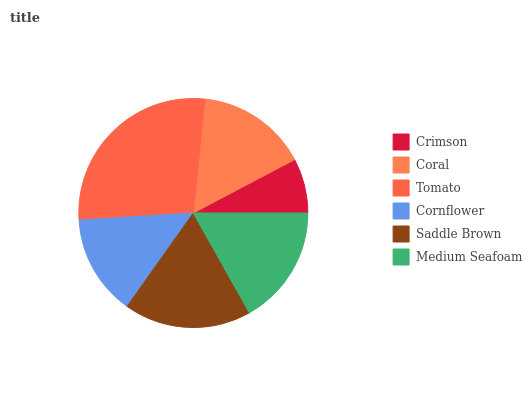Is Crimson the minimum?
Answer yes or no. Yes. Is Tomato the maximum?
Answer yes or no. Yes. Is Coral the minimum?
Answer yes or no. No. Is Coral the maximum?
Answer yes or no. No. Is Coral greater than Crimson?
Answer yes or no. Yes. Is Crimson less than Coral?
Answer yes or no. Yes. Is Crimson greater than Coral?
Answer yes or no. No. Is Coral less than Crimson?
Answer yes or no. No. Is Medium Seafoam the high median?
Answer yes or no. Yes. Is Coral the low median?
Answer yes or no. Yes. Is Tomato the high median?
Answer yes or no. No. Is Crimson the low median?
Answer yes or no. No. 